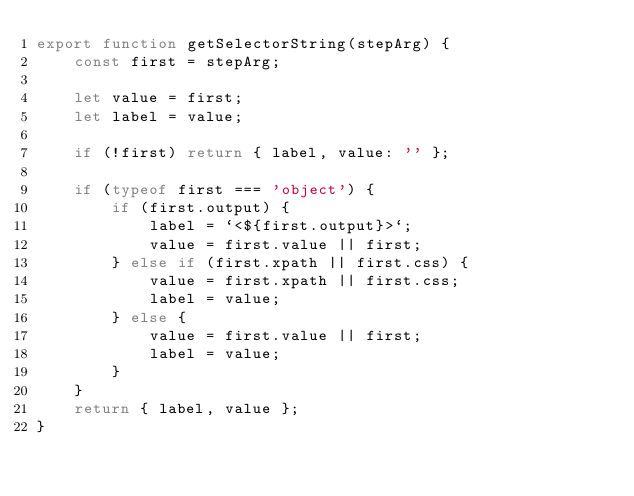<code> <loc_0><loc_0><loc_500><loc_500><_JavaScript_>export function getSelectorString(stepArg) {
    const first = stepArg;

    let value = first;
    let label = value;

    if (!first) return { label, value: '' };

    if (typeof first === 'object') {
        if (first.output) {
            label = `<${first.output}>`;
            value = first.value || first;
        } else if (first.xpath || first.css) {
            value = first.xpath || first.css;
            label = value;
        } else {
            value = first.value || first;
            label = value;
        }
    }
    return { label, value };
}</code> 